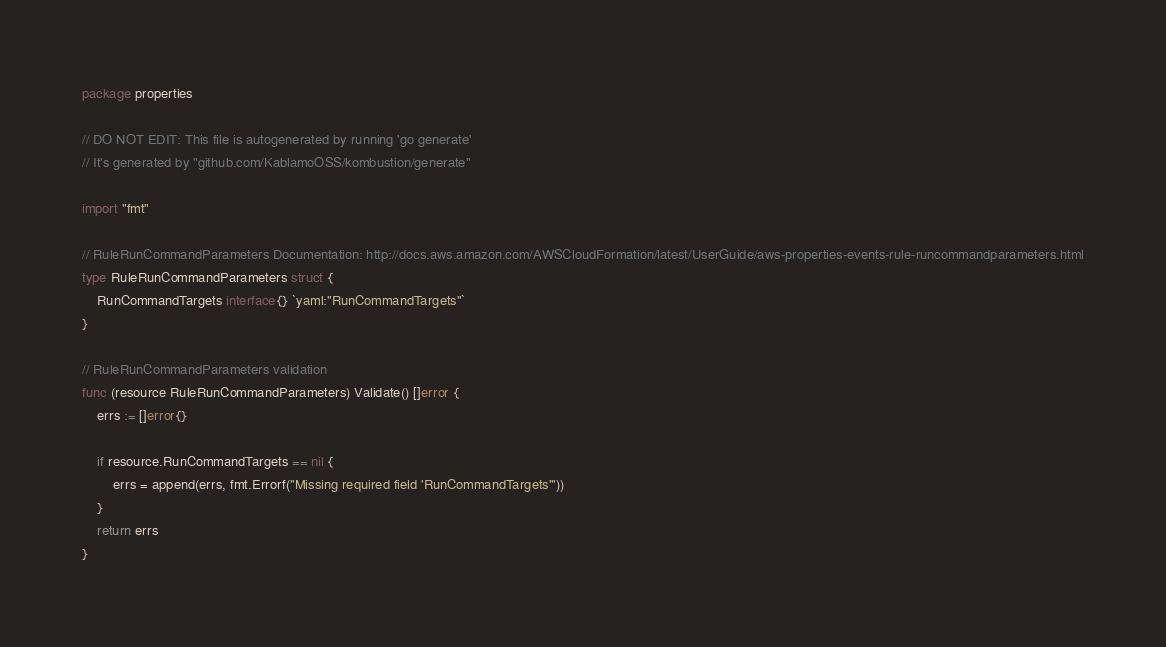Convert code to text. <code><loc_0><loc_0><loc_500><loc_500><_Go_>package properties

// DO NOT EDIT: This file is autogenerated by running 'go generate'
// It's generated by "github.com/KablamoOSS/kombustion/generate"

import "fmt"

// RuleRunCommandParameters Documentation: http://docs.aws.amazon.com/AWSCloudFormation/latest/UserGuide/aws-properties-events-rule-runcommandparameters.html
type RuleRunCommandParameters struct {
	RunCommandTargets interface{} `yaml:"RunCommandTargets"`
}

// RuleRunCommandParameters validation
func (resource RuleRunCommandParameters) Validate() []error {
	errs := []error{}

	if resource.RunCommandTargets == nil {
		errs = append(errs, fmt.Errorf("Missing required field 'RunCommandTargets'"))
	}
	return errs
}
</code> 